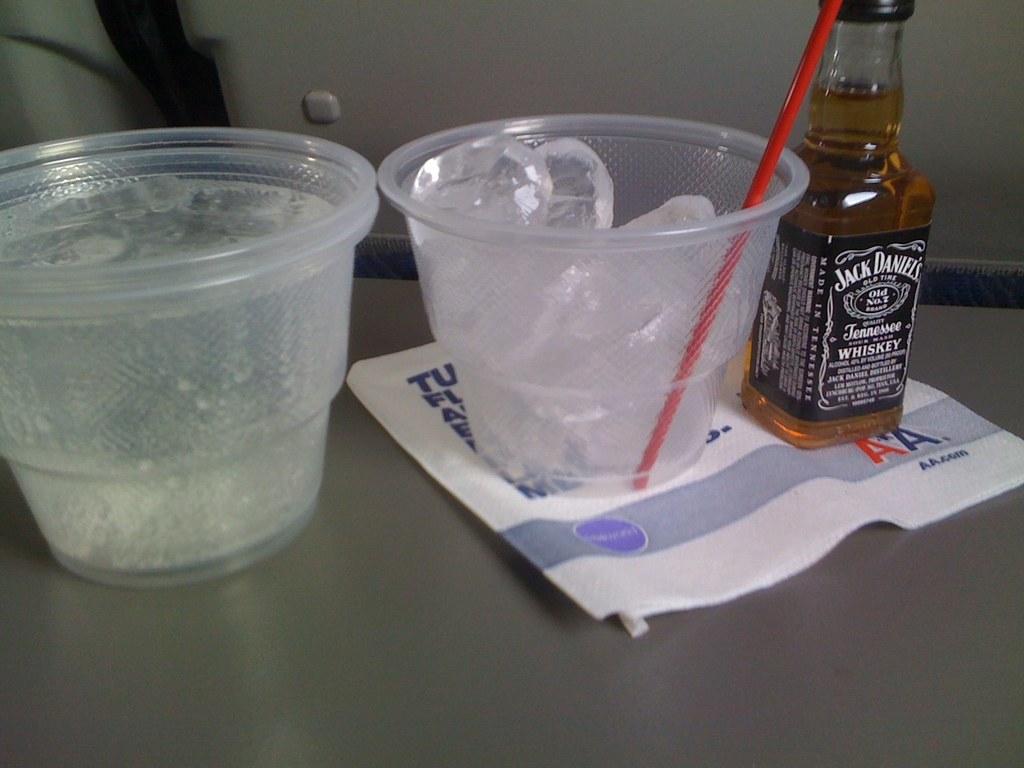What brand of whiskey is in the bottle?
Offer a terse response. Jack daniels. 